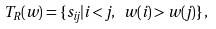Convert formula to latex. <formula><loc_0><loc_0><loc_500><loc_500>T _ { R } ( w ) = \{ s _ { i j } | i < j , \ w ( i ) > w ( j ) \} \, ,</formula> 